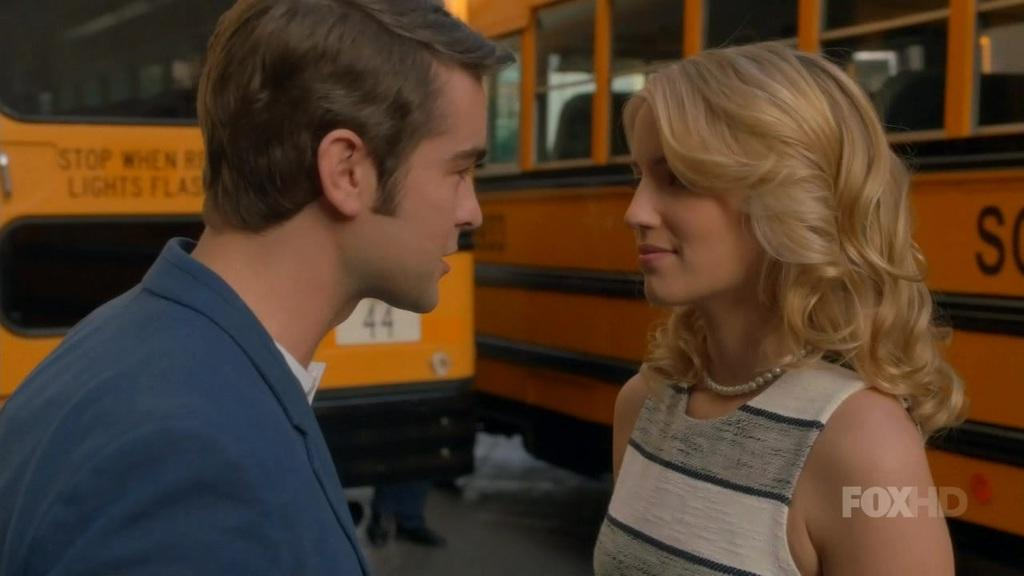How many people are in the image? There are two persons in the image. What are the two persons doing? The two persons are looking at each other. What can be seen in the background of the image? There are vehicles visible in the background of the image. Can you tell me how many frogs are sitting on the map in the image? There are no frogs or maps present in the image. What type of care is being provided to the person in the image? There is no indication of care being provided in the image; the two persons are simply looking at each other. 